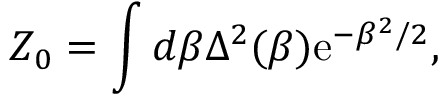<formula> <loc_0><loc_0><loc_500><loc_500>Z _ { 0 } = \int d \beta \Delta ^ { 2 } ( \beta ) e ^ { - \beta ^ { 2 } / 2 } ,</formula> 